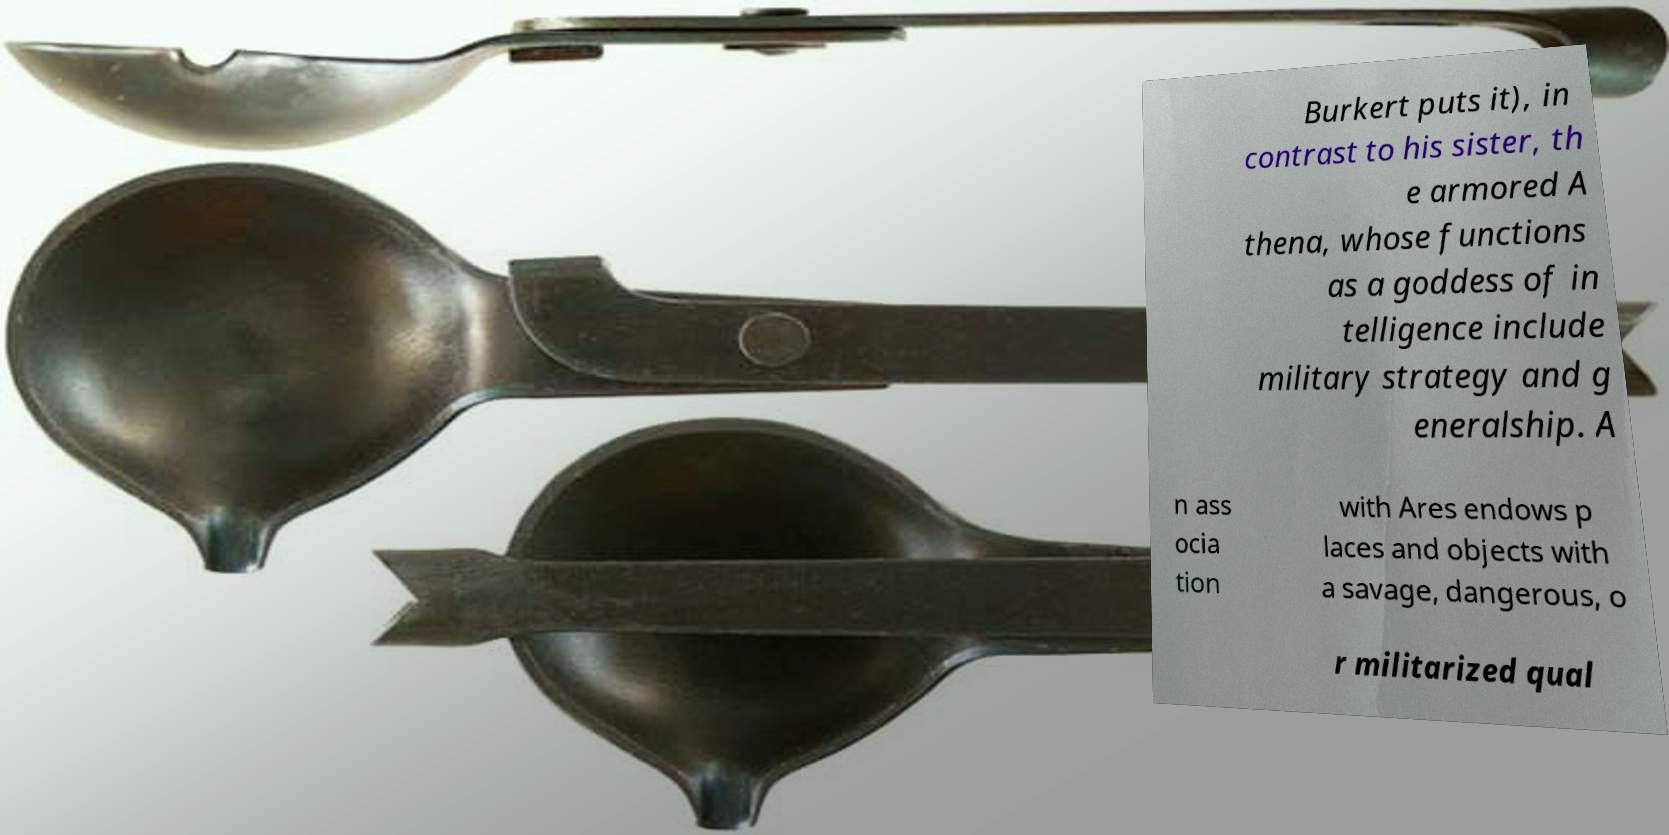Could you extract and type out the text from this image? Burkert puts it), in contrast to his sister, th e armored A thena, whose functions as a goddess of in telligence include military strategy and g eneralship. A n ass ocia tion with Ares endows p laces and objects with a savage, dangerous, o r militarized qual 